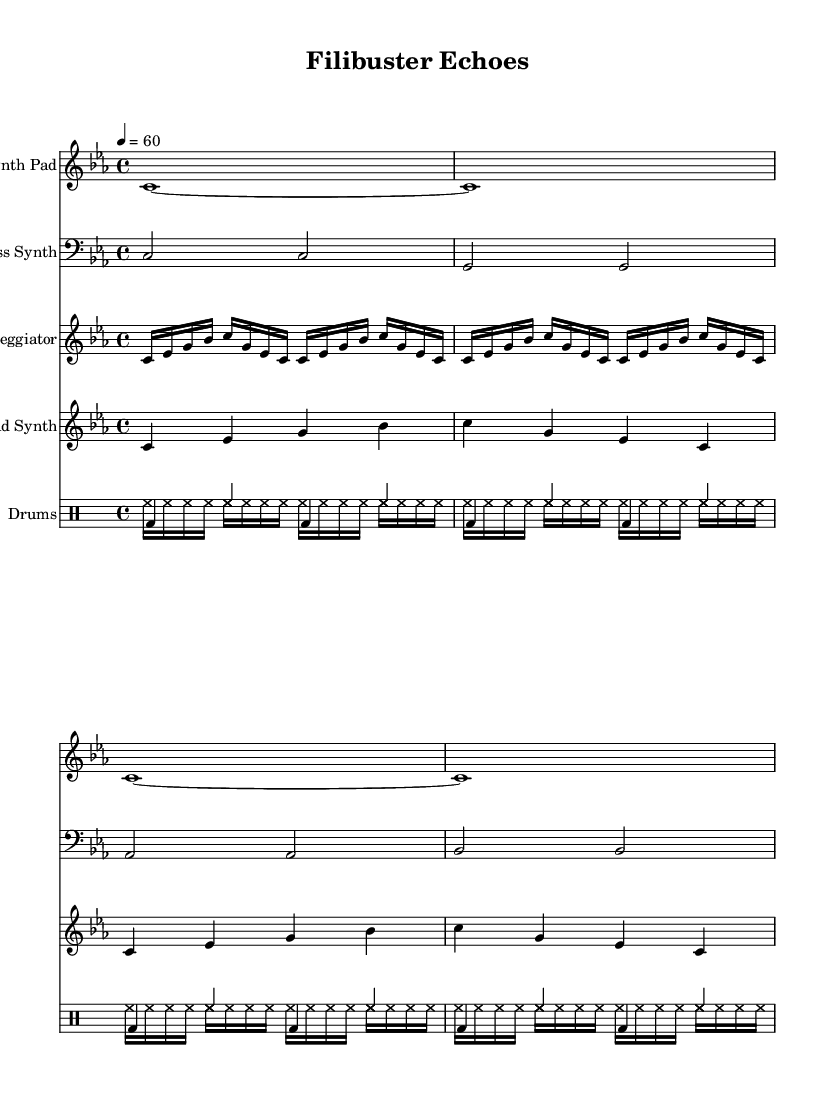What is the key signature of this music? The key signature is C minor, indicated by three flats in the key signature area of the sheet music.
Answer: C minor What is the time signature of this music? The time signature is 4/4, represented in the top left corner of the first system of the sheet music.
Answer: 4/4 What is the tempo marking of this composition? The tempo marking is quarter note equals sixty beats per minute, shown at the beginning of the score.
Answer: 60 How many staves are present in the score? There are five distinct staves present: one each for the Synth Pad, Bass Synth, Arpeggiator, Lead Synth, and one for the drums, indicated by the labels.
Answer: Five What type of composition is this? This composition is classified as ambient electronic, inferred from its electronic instrumentation and style of arrangement.
Answer: Ambient electronic How is rhythm constructed in the drum section? The rhythm in the drum section is constructed with a repeated pattern of bass and hi-hat notes, consistently maintaining a steady 4/4 pulse throughout.
Answer: Repeated pattern What is the instrument name for the lowest voice in the score? The lowest voice in the score is designated as "Bass Synth," which is clearly labeled on the third staff.
Answer: Bass Synth 